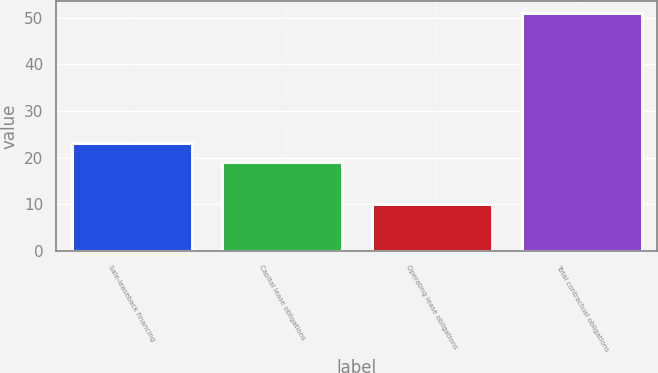<chart> <loc_0><loc_0><loc_500><loc_500><bar_chart><fcel>Sale-leaseback financing<fcel>Capital lease obligations<fcel>Operating lease obligations<fcel>Total contractual obligations<nl><fcel>23.1<fcel>19<fcel>10<fcel>51<nl></chart> 